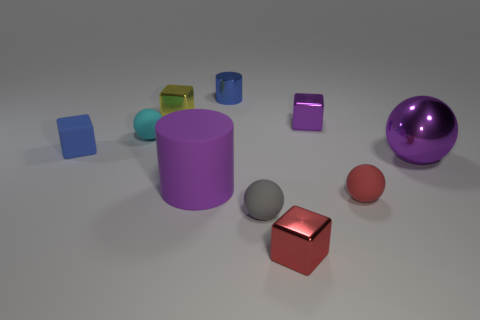What materials do these objects appear to be made of? These objects seem to have a smooth and reflective surface, suggesting they are made of materials like plastic or polished metal, giving them a shiny finish suitable for a synthetic or controlled environment. 